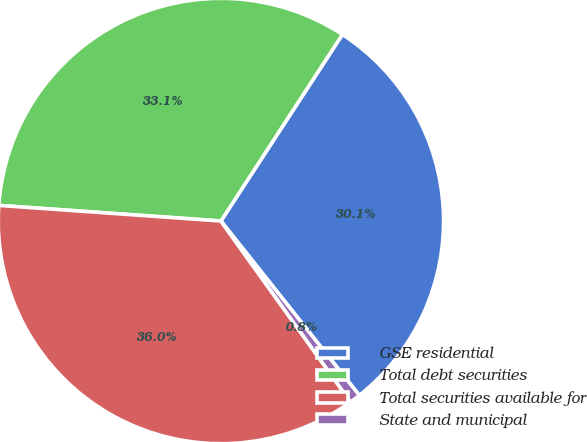<chart> <loc_0><loc_0><loc_500><loc_500><pie_chart><fcel>GSE residential<fcel>Total debt securities<fcel>Total securities available for<fcel>State and municipal<nl><fcel>30.13%<fcel>33.07%<fcel>36.01%<fcel>0.79%<nl></chart> 